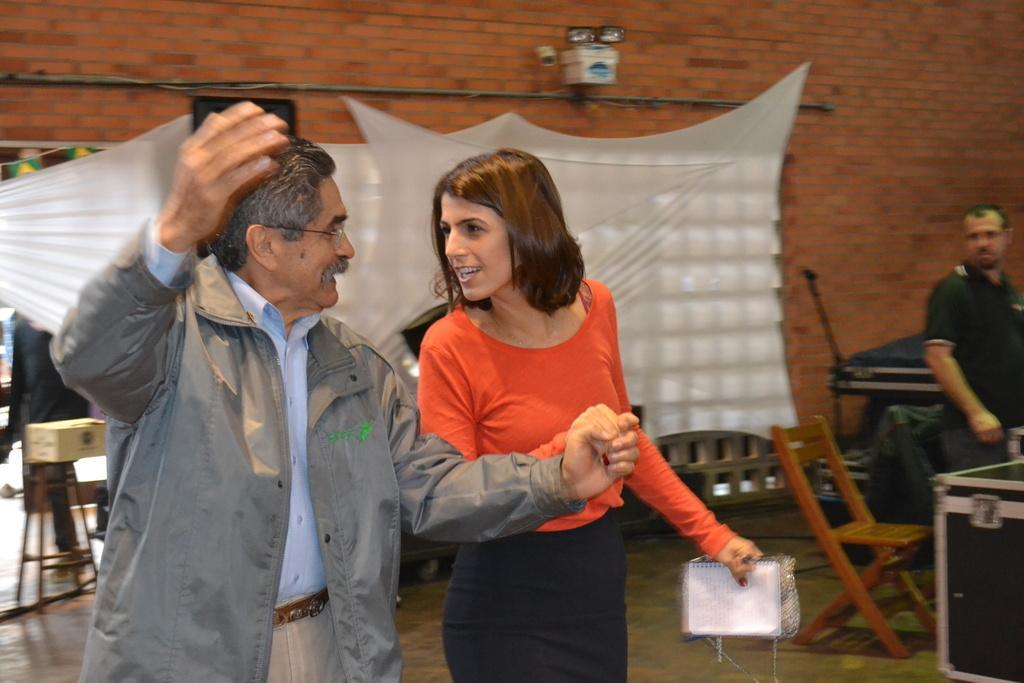In one or two sentences, can you explain what this image depicts? In this picture we can see 2 people holding hands and looking at each other. In the background, we can see a person, white curtains, chairs, tables, and a brick wall with lights. 